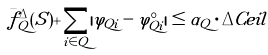<formula> <loc_0><loc_0><loc_500><loc_500>\bar { f } ^ { \Delta } _ { Q } ( S ) + \sum _ { i \in Q } | \varphi _ { Q i } - \varphi ^ { \circ } _ { Q i } | \leq \alpha _ { Q } \cdot \Delta C e i l</formula> 